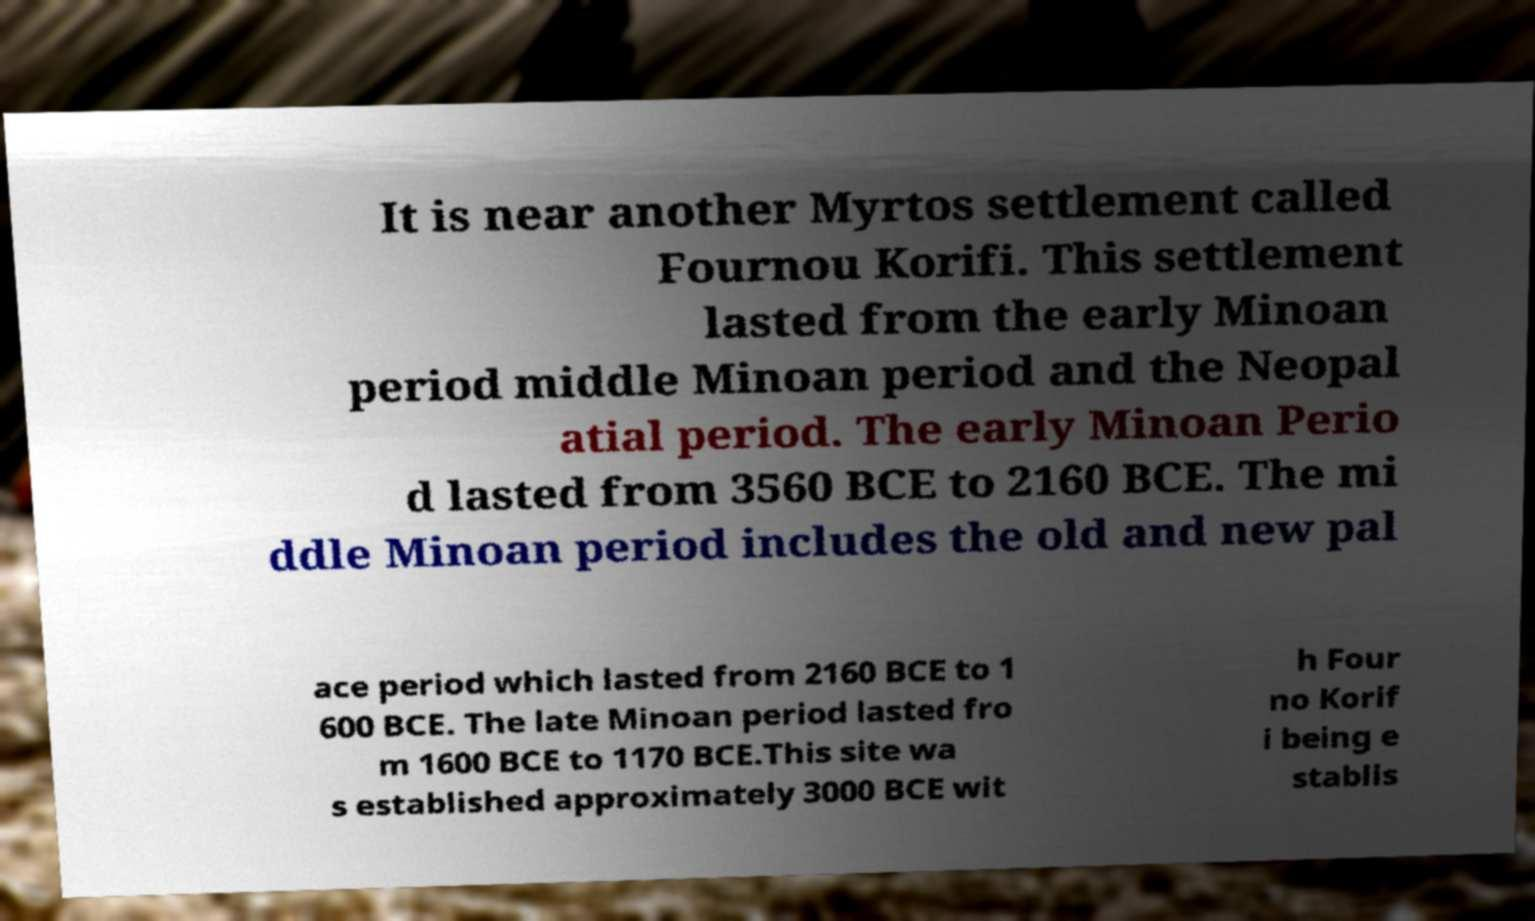Could you assist in decoding the text presented in this image and type it out clearly? It is near another Myrtos settlement called Fournou Korifi. This settlement lasted from the early Minoan period middle Minoan period and the Neopal atial period. The early Minoan Perio d lasted from 3560 BCE to 2160 BCE. The mi ddle Minoan period includes the old and new pal ace period which lasted from 2160 BCE to 1 600 BCE. The late Minoan period lasted fro m 1600 BCE to 1170 BCE.This site wa s established approximately 3000 BCE wit h Four no Korif i being e stablis 